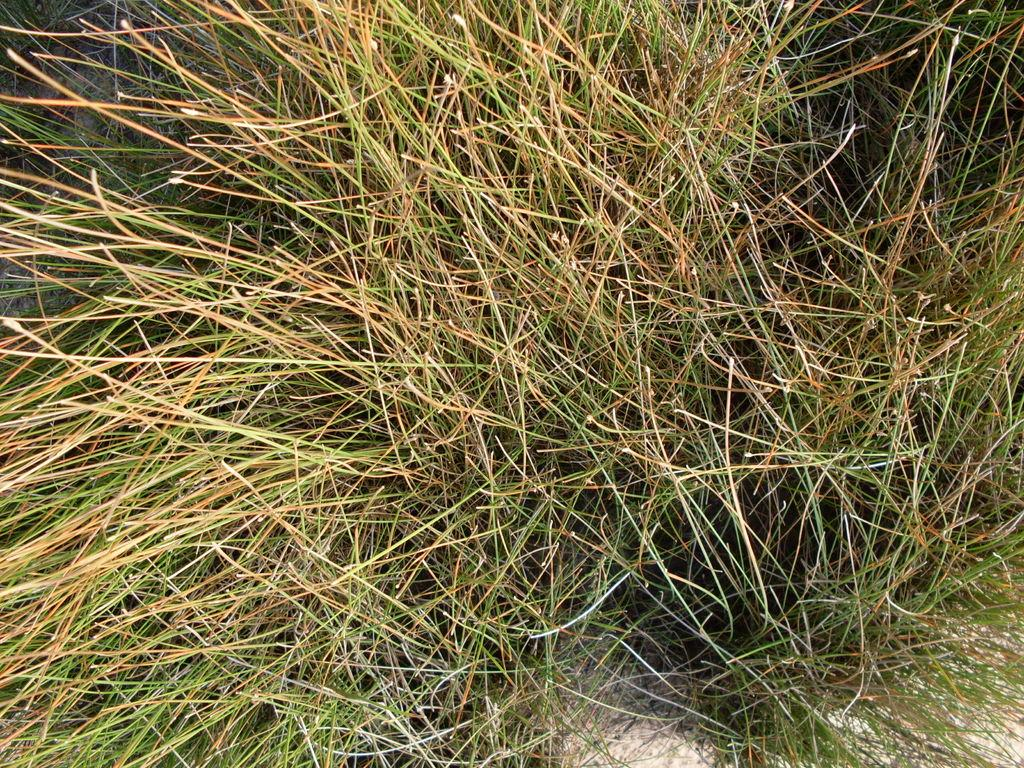What is the primary element visible in the image? The picture consists of grass. What type of environment might the grass be located in? The grass might be located in a natural setting, such as a field or park. What might be the color of the grass in the image? The color of the grass in the image might be green, as that is the typical color of grass. Can you see your friend jumping over the grass in the image? There is no friend or jumping activity visible in the image; it only consists of grass. 